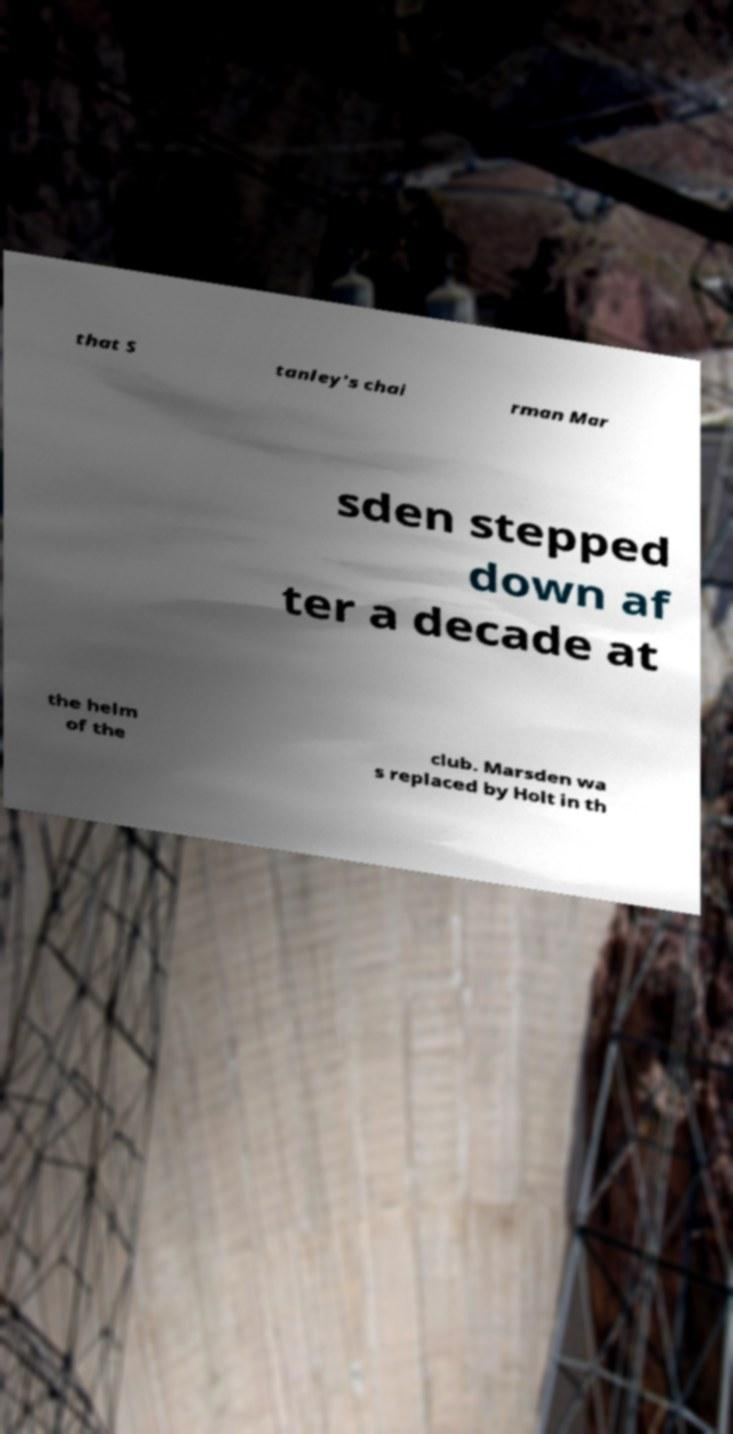I need the written content from this picture converted into text. Can you do that? that S tanley's chai rman Mar sden stepped down af ter a decade at the helm of the club. Marsden wa s replaced by Holt in th 